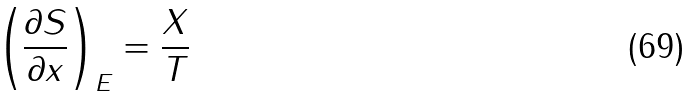Convert formula to latex. <formula><loc_0><loc_0><loc_500><loc_500>\left ( { \frac { \partial S } { \partial x } } \right ) _ { E } = { \frac { X } { T } }</formula> 